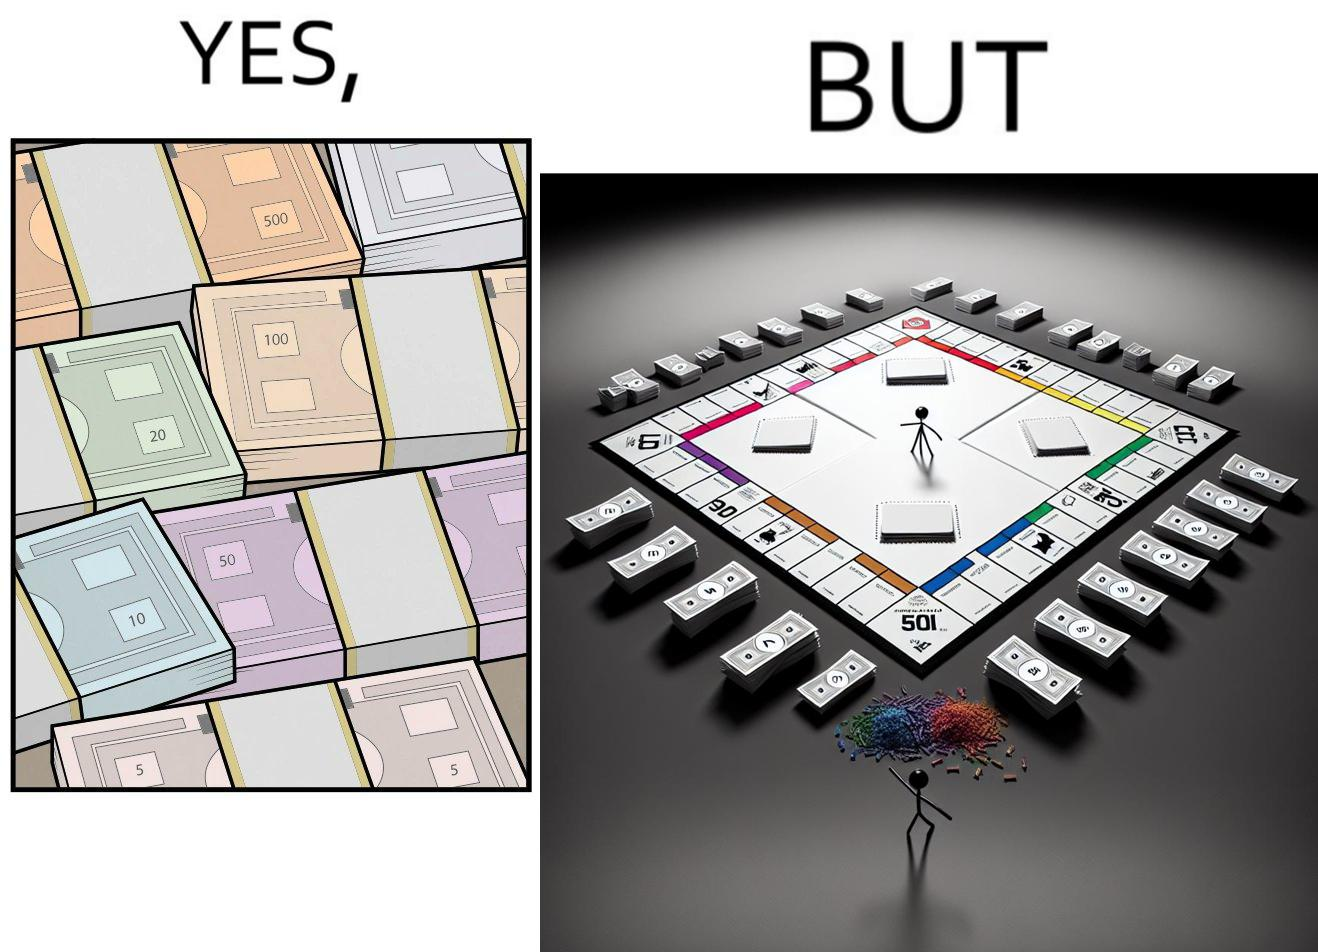What do you see in each half of this image? In the left part of the image: many different color currency notes' bundles In the right part of the image: a board of game monopoly with many different color currency notes' bundles 